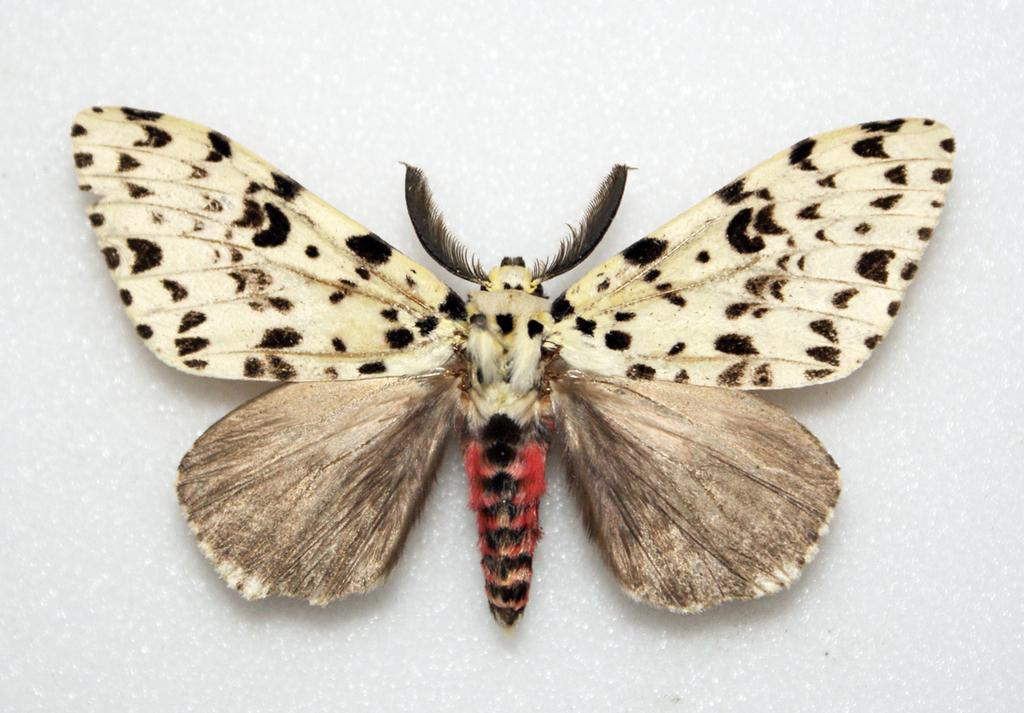What type of creature is present in the image? There is a butterfly in the image. Can you describe the appearance of the butterfly? The butterfly has a multi-colored appearance, including white, red, and black. How many folds are visible on the bomb in the image? There is no bomb present in the image; it features a butterfly with a multi-colored appearance. 